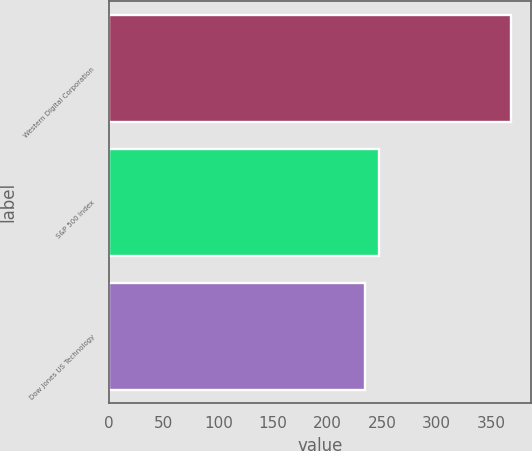<chart> <loc_0><loc_0><loc_500><loc_500><bar_chart><fcel>Western Digital Corporation<fcel>S&P 500 Index<fcel>Dow Jones US Technology<nl><fcel>367.86<fcel>247.37<fcel>233.98<nl></chart> 